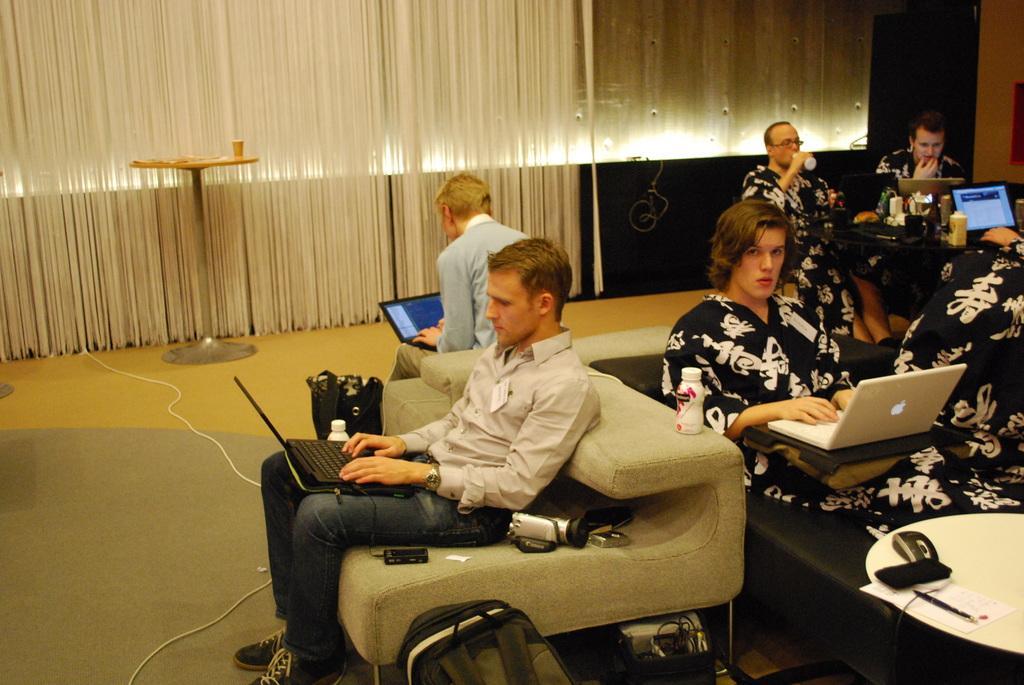Describe this image in one or two sentences. This picture shows a group of people seated and working on the laptops and we see a man drinking and we see few blinds 